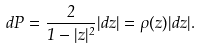Convert formula to latex. <formula><loc_0><loc_0><loc_500><loc_500>d P = \frac { 2 } { 1 - | z | ^ { 2 } } | d z | = \rho ( z ) | d z | .</formula> 